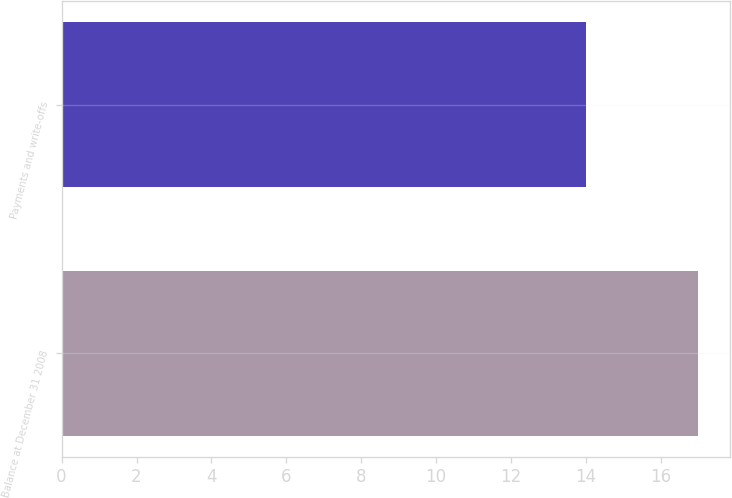Convert chart to OTSL. <chart><loc_0><loc_0><loc_500><loc_500><bar_chart><fcel>Balance at December 31 2008<fcel>Payments and write-offs<nl><fcel>17<fcel>14<nl></chart> 